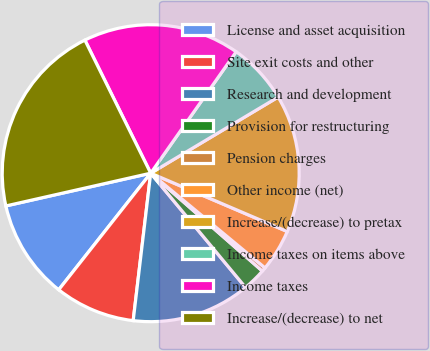Convert chart to OTSL. <chart><loc_0><loc_0><loc_500><loc_500><pie_chart><fcel>License and asset acquisition<fcel>Site exit costs and other<fcel>Research and development<fcel>Provision for restructuring<fcel>Pension charges<fcel>Other income (net)<fcel>Increase/(decrease) to pretax<fcel>Income taxes on items above<fcel>Income taxes<fcel>Increase/(decrease) to net<nl><fcel>10.83%<fcel>8.75%<fcel>12.91%<fcel>2.52%<fcel>0.44%<fcel>4.59%<fcel>14.99%<fcel>6.67%<fcel>17.07%<fcel>21.23%<nl></chart> 